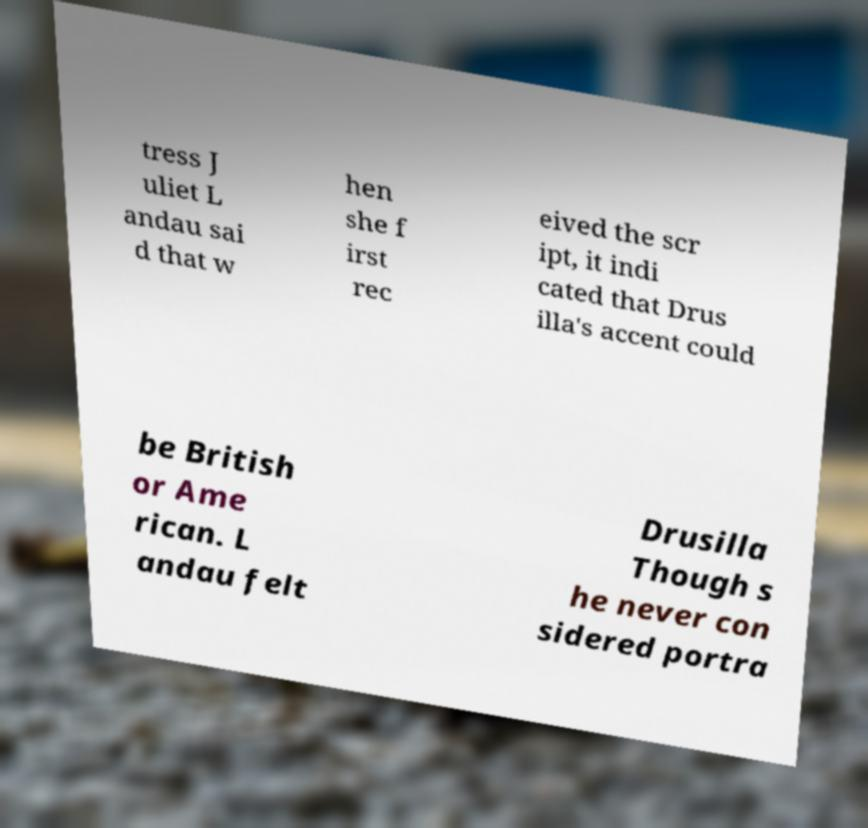For documentation purposes, I need the text within this image transcribed. Could you provide that? tress J uliet L andau sai d that w hen she f irst rec eived the scr ipt, it indi cated that Drus illa's accent could be British or Ame rican. L andau felt Drusilla Though s he never con sidered portra 